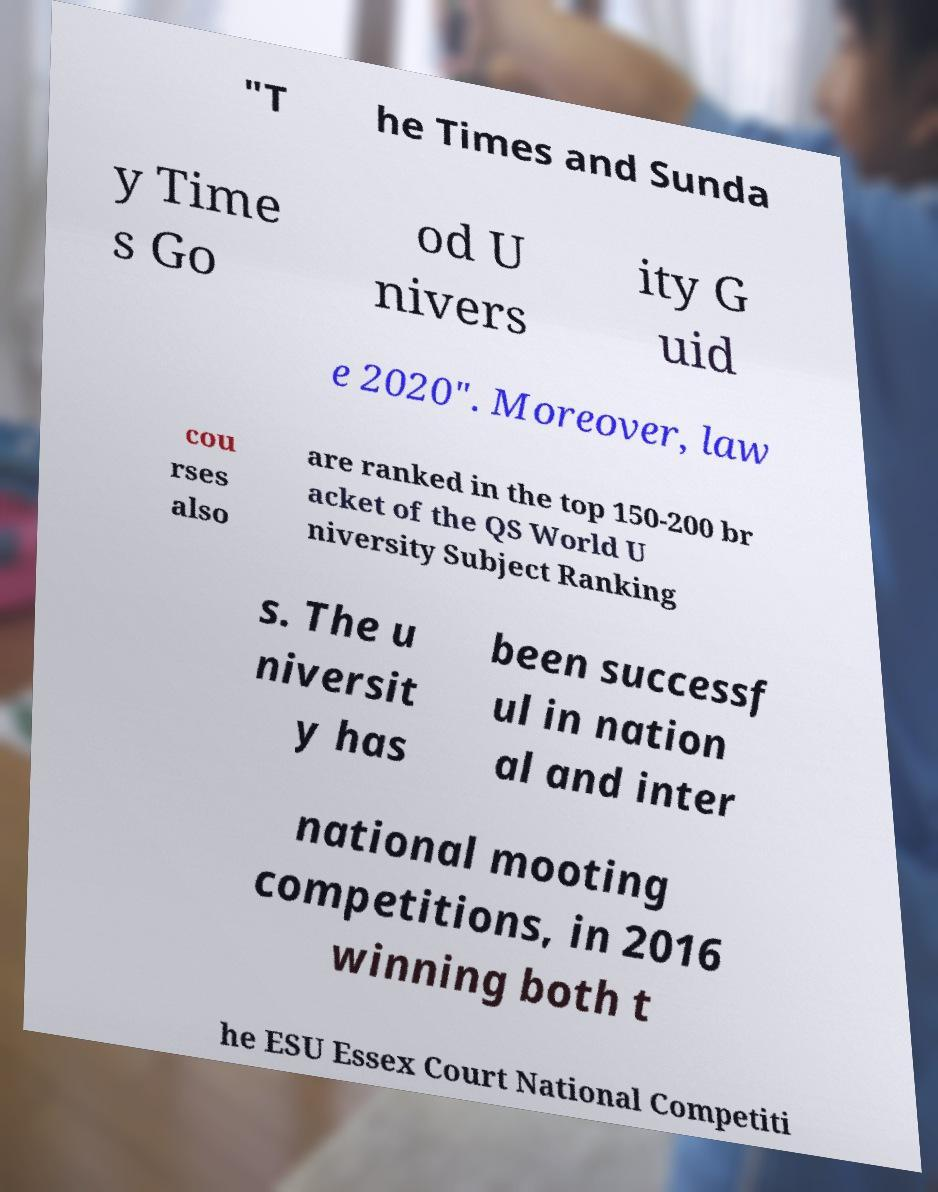For documentation purposes, I need the text within this image transcribed. Could you provide that? "T he Times and Sunda y Time s Go od U nivers ity G uid e 2020". Moreover, law cou rses also are ranked in the top 150-200 br acket of the QS World U niversity Subject Ranking s. The u niversit y has been successf ul in nation al and inter national mooting competitions, in 2016 winning both t he ESU Essex Court National Competiti 